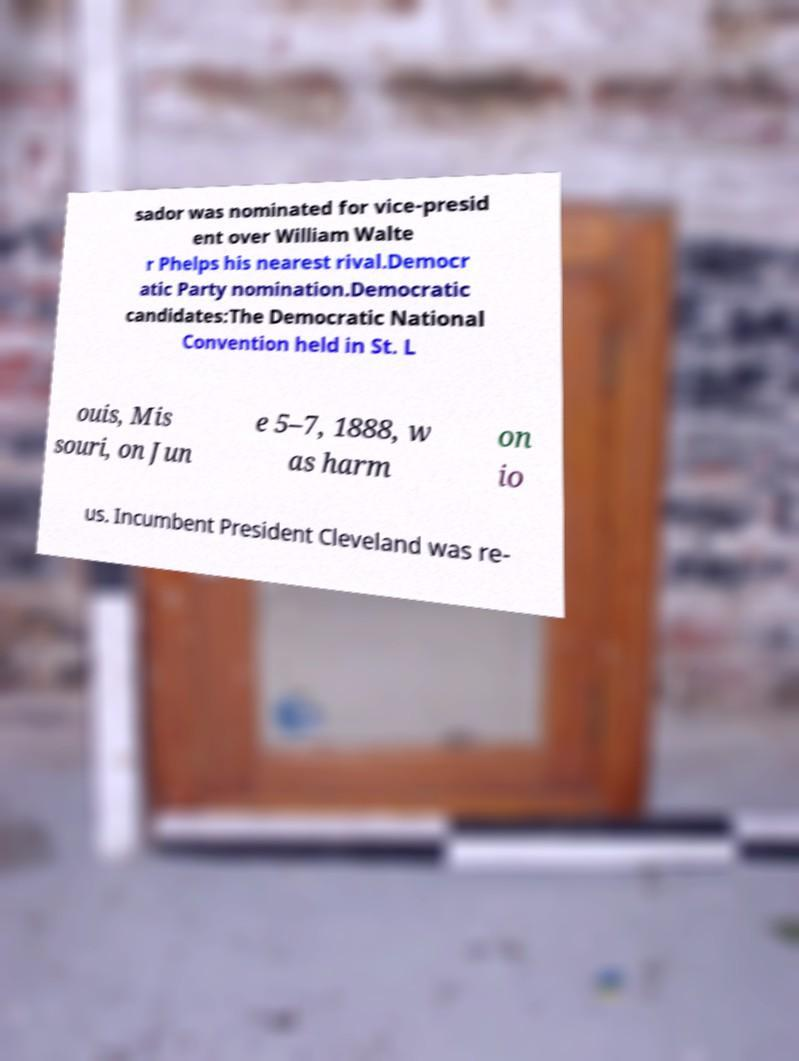Please identify and transcribe the text found in this image. sador was nominated for vice-presid ent over William Walte r Phelps his nearest rival.Democr atic Party nomination.Democratic candidates:The Democratic National Convention held in St. L ouis, Mis souri, on Jun e 5–7, 1888, w as harm on io us. Incumbent President Cleveland was re- 